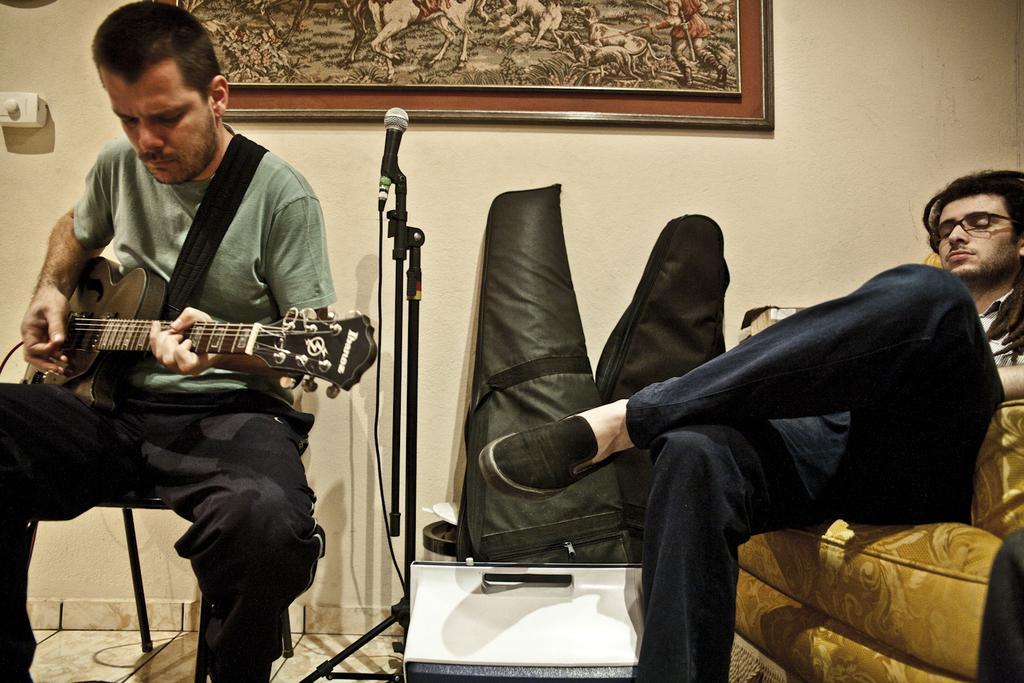Can you describe this image briefly? In this image i can see 2 persons. The person on the left corner is holding a guitar in his hand and sitting on a chair. The person on the right corner is sitting on a couch. I can see a microphone in between them. In the background i can see a wall and a photo frame. 